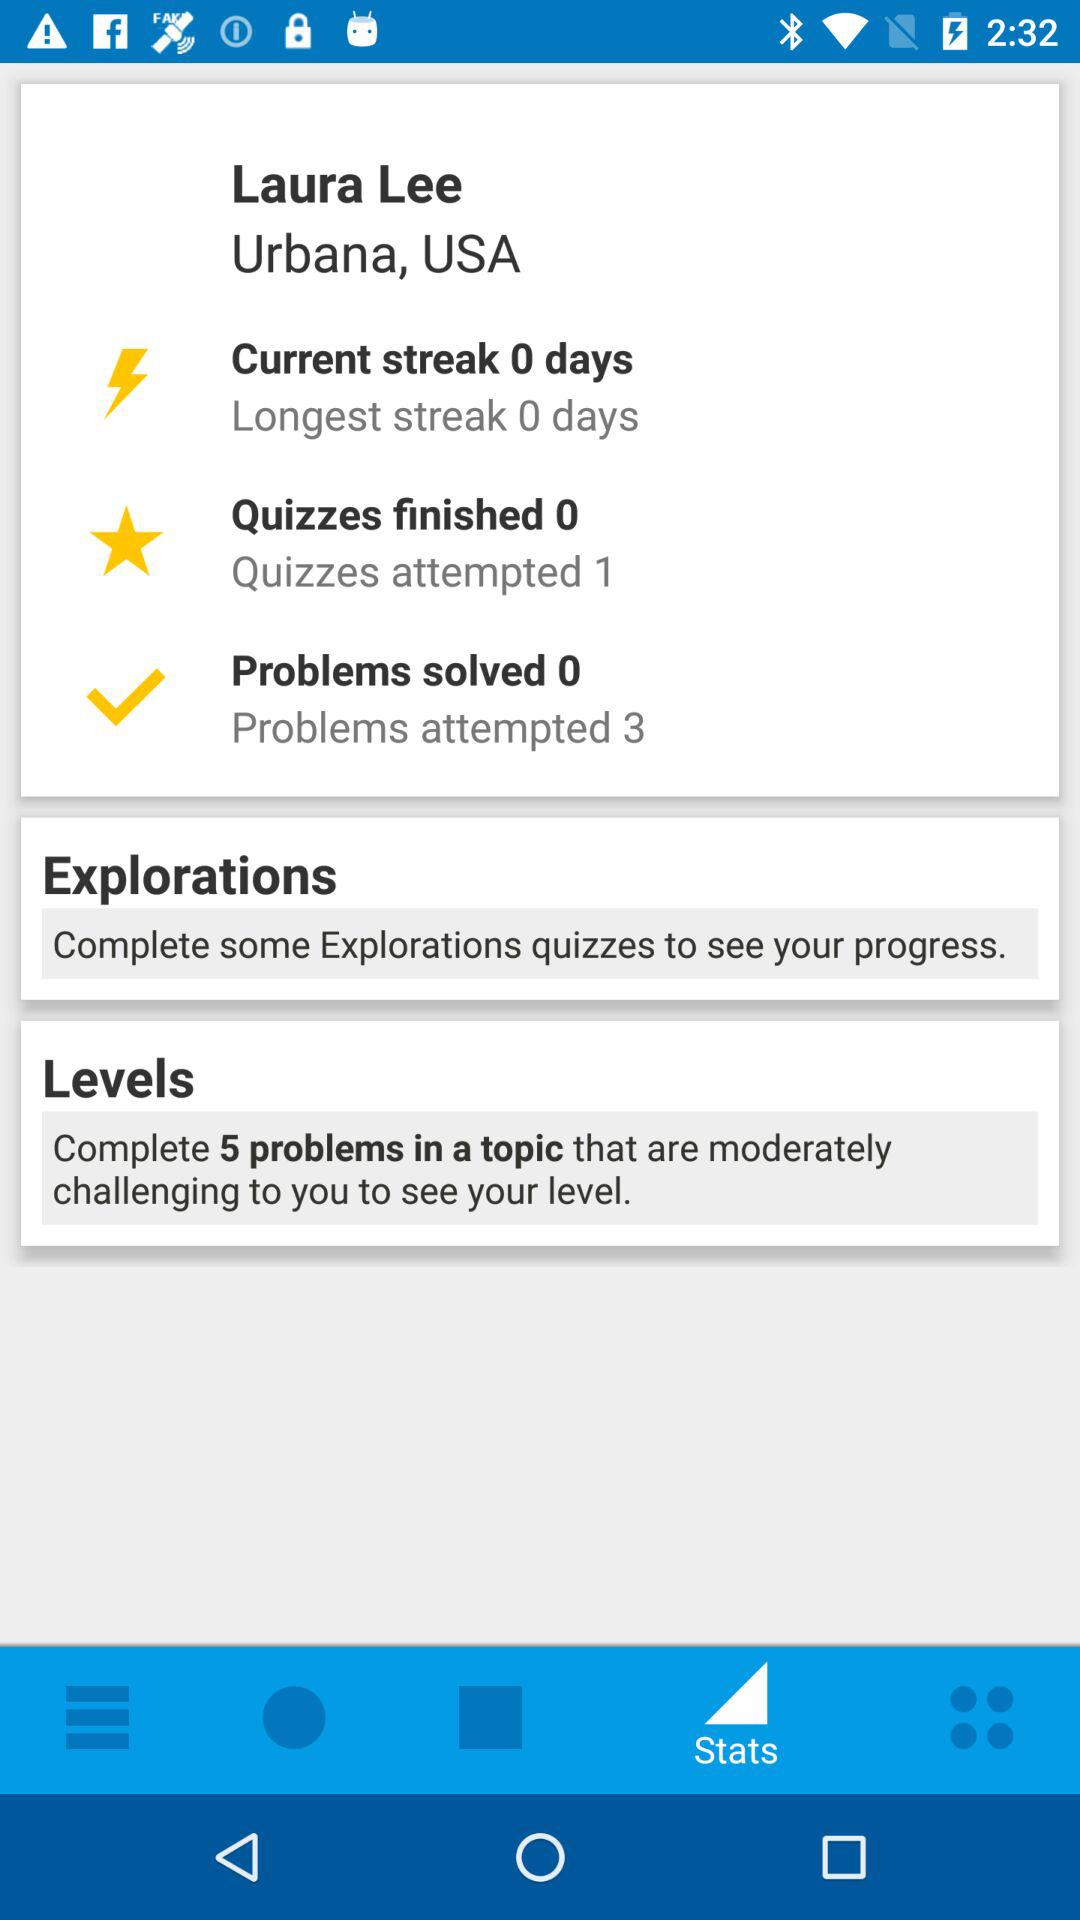What is the name of the user? The name of the user is Laura Lee. 